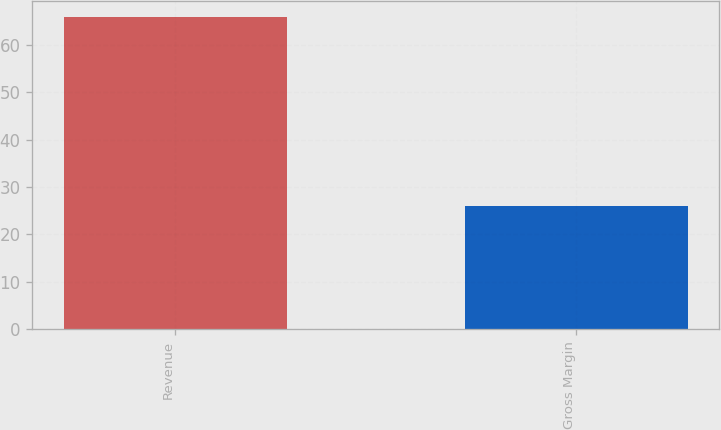Convert chart. <chart><loc_0><loc_0><loc_500><loc_500><bar_chart><fcel>Revenue<fcel>Gross Margin<nl><fcel>66<fcel>26<nl></chart> 